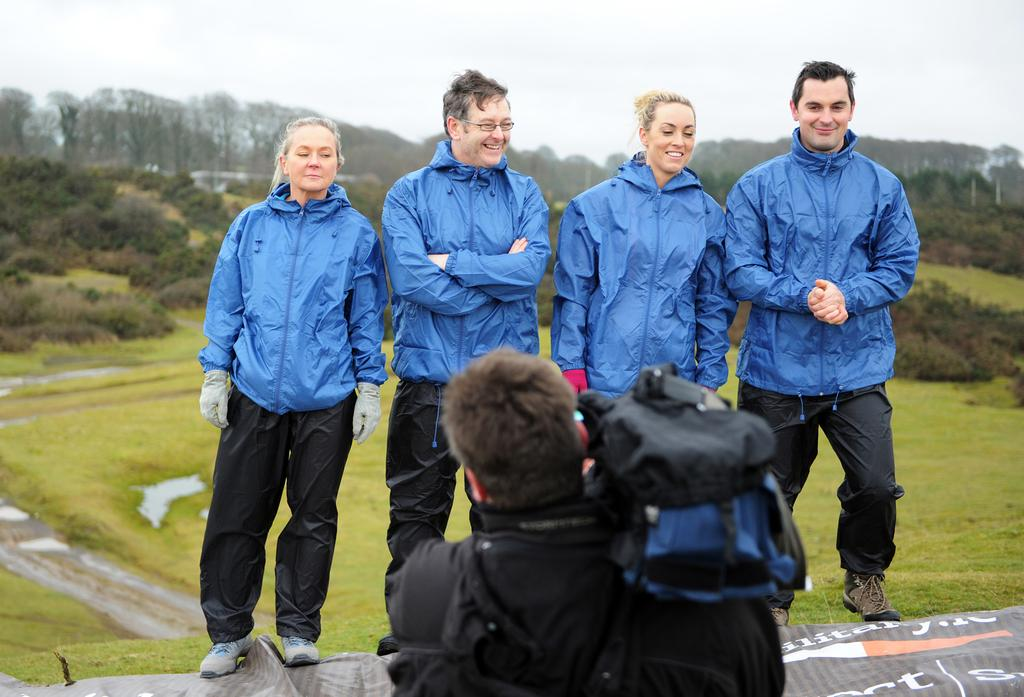How many people are present in the image? There are four people standing on the ground. What is the surrounding environment like? There is a lot of grass and greenery around the people. What is the person in front of the group doing? A person is capturing their photo in front of them. What type of punishment is being given to the people in the image? There is no indication of punishment in the image; the people are standing and having their photo taken. 